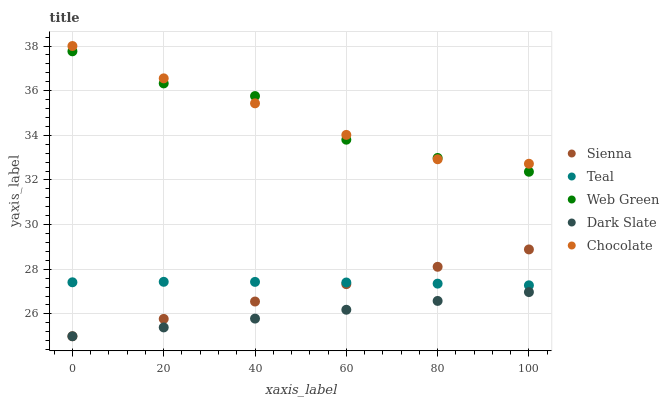Does Dark Slate have the minimum area under the curve?
Answer yes or no. Yes. Does Chocolate have the maximum area under the curve?
Answer yes or no. Yes. Does Web Green have the minimum area under the curve?
Answer yes or no. No. Does Web Green have the maximum area under the curve?
Answer yes or no. No. Is Sienna the smoothest?
Answer yes or no. Yes. Is Web Green the roughest?
Answer yes or no. Yes. Is Dark Slate the smoothest?
Answer yes or no. No. Is Dark Slate the roughest?
Answer yes or no. No. Does Sienna have the lowest value?
Answer yes or no. Yes. Does Web Green have the lowest value?
Answer yes or no. No. Does Chocolate have the highest value?
Answer yes or no. Yes. Does Web Green have the highest value?
Answer yes or no. No. Is Teal less than Web Green?
Answer yes or no. Yes. Is Web Green greater than Sienna?
Answer yes or no. Yes. Does Chocolate intersect Web Green?
Answer yes or no. Yes. Is Chocolate less than Web Green?
Answer yes or no. No. Is Chocolate greater than Web Green?
Answer yes or no. No. Does Teal intersect Web Green?
Answer yes or no. No. 